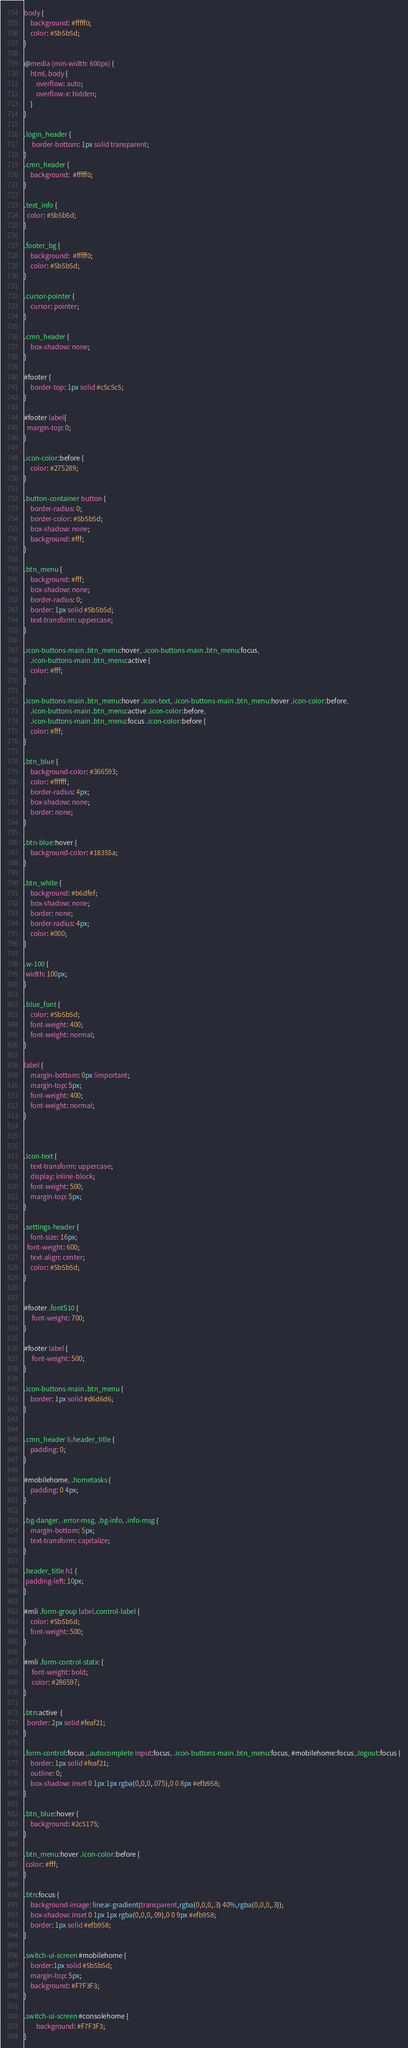Convert code to text. <code><loc_0><loc_0><loc_500><loc_500><_CSS_>body {
	background: #fffff0;
	color: #5b5b5d;	
}

@media (min-width: 600px) {
	html, body {
	    overflow: auto;
	    overflow-x: hidden;
	}
}

.login_header {
     border-bottom: 1px solid transparent;	
}
.cmn_header {
	background:  #fffff0;
}

.text_info {
  color: #5b5b5d;	
}

.footer_bg {
	background:  #fffff0;
	color: #5b5b5d;
}

.cursor-pointer {
	cursor: pointer;
}

.cmn_header {
	box-shadow: none;
}

#footer {
	border-top: 1px solid #c5c5c5;
}

#footer label{ 
  margin-top: 0;	
}
	
.icon-color:before {
	color: #275289;
}

.button-container button {
	border-radius: 0;
	border-color: #5b5b5d;
	box-shadow: none;
	background: #fff;
}

.btn_menu {
	background: #fff;
	box-shadow: none;
	border-radius: 0;
	border: 1px solid #5b5b5d;
	text-transform: uppercase;
}

.icon-buttons-main .btn_menu:hover, .icon-buttons-main .btn_menu:focus,
	.icon-buttons-main .btn_menu:active {
	color: #fff;
}

.icon-buttons-main .btn_menu:hover .icon-text, .icon-buttons-main .btn_menu:hover .icon-color:before,
	.icon-buttons-main .btn_menu:active .icon-color:before,
	.icon-buttons-main .btn_menu:focus .icon-color:before {
	color: #fff;
}

.btn_blue {
	background-color: #366593;
	color: #ffffff;
	border-radius: 4px;
	box-shadow: none;
	border: none;
}

.btn-blue:hover {
	background-color: #18355a;
}

.btn_white {
	background: #b6dfef;
	box-shadow: none;
	border: none;
	border-radius: 4px;
	color: #000;
}

.w-100 {
 width: 100px;	
}

.blue_font {
	color: #5b5b5d;
	font-weight: 400;
	font-weight: normal;
}

label {
	margin-bottom: 0px !important;
	margin-top: 5px;
	font-weight: 400;
	font-weight: normal;
}



.icon-text {
	text-transform: uppercase;
	display: inline-block;
	font-weight: 500;
	margin-top: 5px;
}

.settings-header {
	font-size: 16px;
  font-weight: 600;	
	text-align: center;
	color: #5b5b5d;
}


#footer .fontS10 {
	 font-weight: 700;
}

#footer label {
	 font-weight: 500;
}

.icon-buttons-main .btn_menu {
	border: 1px solid #d6d6d6;
}


.cmn_header li.header_title {
	padding: 0;
}

#mobilehome, .hometasks {
	padding: 0 4px;
}

.bg-danger, .error-msg, .bg-info, .info-msg {
	margin-bottom: 5px;
	text-transform: capitalize;
}

.header_title h1 {
 padding-left: 10px;	
}

#mli .form-group label.control-label {
	color: #5b5b5d;
	font-weight: 500;
}

#mli .form-control-static {
	 font-weight: bold;
	 color: #286597;
}

.btn:active  {
  border: 2px solid #feaf21;
}  

.form-control:focus ,.autocomplete input:focus, .icon-buttons-main .btn_menu:focus, #mobilehome:focus,.logout:focus {
	border: 1px solid #feaf21;
    outline: 0;
    box-shadow: inset 0 1px 1px rgba(0,0,0,.075),0 0 8px #efb958;
}
	
.btn_blue:hover {
    background: #2c5175;
}

.btn_menu:hover .icon-color:before {
 color: #fff;	
}

.btn:focus {
	background-image: linear-gradient(transparent,rgba(0,0,0,.3) 40%,rgba(0,0,0,.3));
	box-shadow: inset 0 1px 1px rgba(0,0,0,.09),0 0 9px #efb958;
	border: 1px solid #efb958;
}

.switch-ui-screen #mobilehome {
	border:1px solid #5b5b5d;
	margin-top: 5px;
	background: #F7F3F3;
}

.switch-ui-screen #consolehome {
	    background: #F7F3F3;
}
</code> 